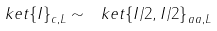<formula> <loc_0><loc_0><loc_500><loc_500>\ k e t { \{ I \} } _ { c , L } \sim \ k e t { \{ I / 2 , I / 2 \} } _ { a a , L }</formula> 